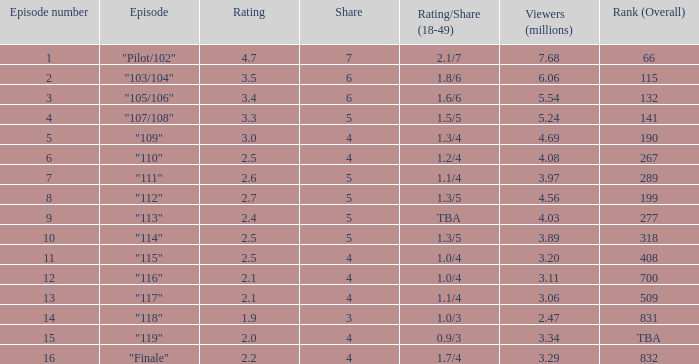WHAT IS THE NUMBER OF VIEWERS WITH EPISODE LARGER THAN 10, RATING SMALLER THAN 2? 2.47. 